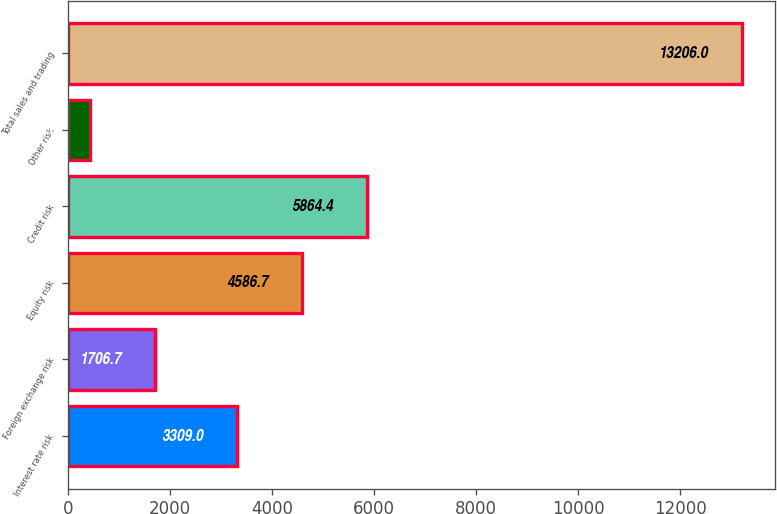<chart> <loc_0><loc_0><loc_500><loc_500><bar_chart><fcel>Interest rate risk<fcel>Foreign exchange risk<fcel>Equity risk<fcel>Credit risk<fcel>Other risk<fcel>Total sales and trading<nl><fcel>3309<fcel>1706.7<fcel>4586.7<fcel>5864.4<fcel>429<fcel>13206<nl></chart> 